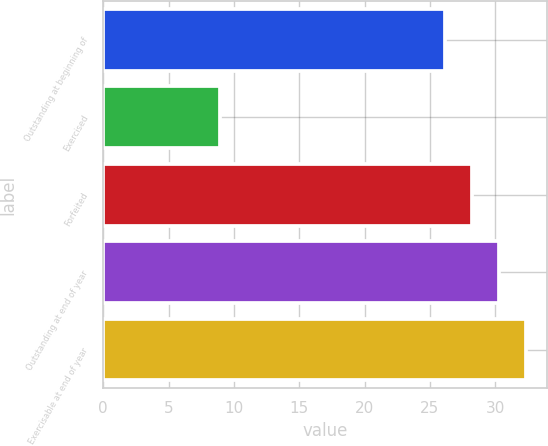<chart> <loc_0><loc_0><loc_500><loc_500><bar_chart><fcel>Outstanding at beginning of<fcel>Exercised<fcel>Forfeited<fcel>Outstanding at end of year<fcel>Exercisable at end of year<nl><fcel>26.14<fcel>8.92<fcel>28.2<fcel>30.26<fcel>32.32<nl></chart> 